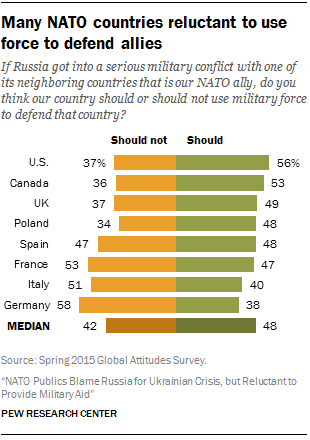Draw attention to some important aspects in this diagram. According to the graph, the second largest green bar value is 0.53. Canada does not use force to defend its allies at a higher percentage than the United States," according to the information provided. 